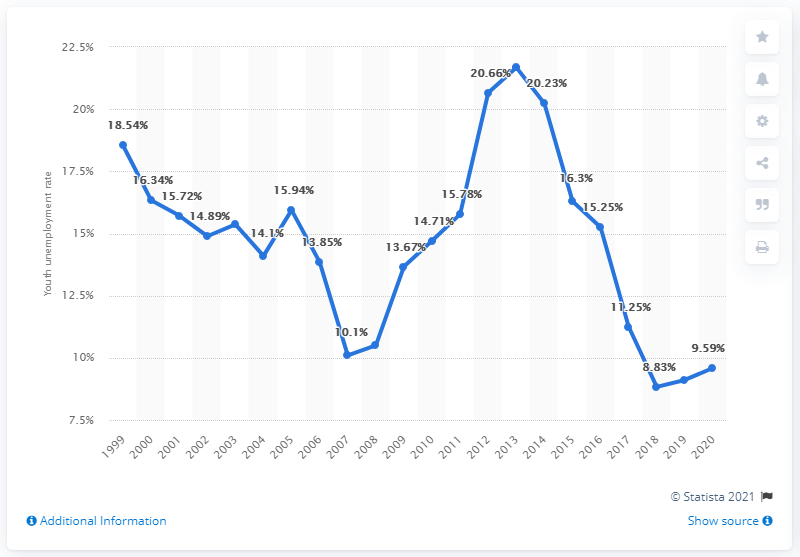Indicate a few pertinent items in this graphic. In 2020, the youth unemployment rate in Slovenia was 9.59%. 